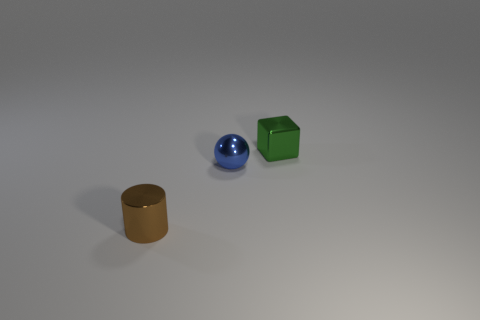Subtract all red cubes. Subtract all blue spheres. How many cubes are left? 1 Add 2 cyan rubber balls. How many objects exist? 5 Subtract all cubes. How many objects are left? 2 Subtract all small blue cubes. Subtract all tiny blue objects. How many objects are left? 2 Add 1 small things. How many small things are left? 4 Add 3 small yellow matte things. How many small yellow matte things exist? 3 Subtract 0 cyan cylinders. How many objects are left? 3 